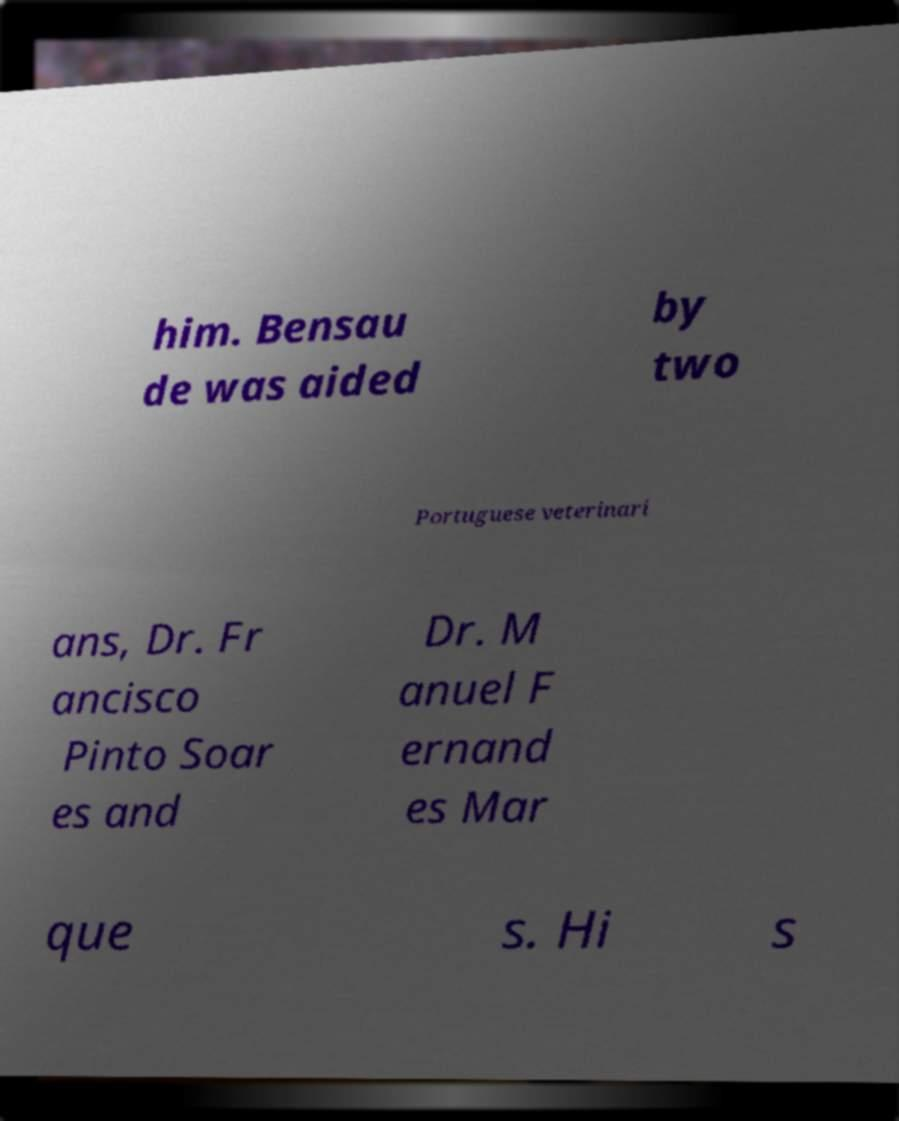What messages or text are displayed in this image? I need them in a readable, typed format. him. Bensau de was aided by two Portuguese veterinari ans, Dr. Fr ancisco Pinto Soar es and Dr. M anuel F ernand es Mar que s. Hi s 